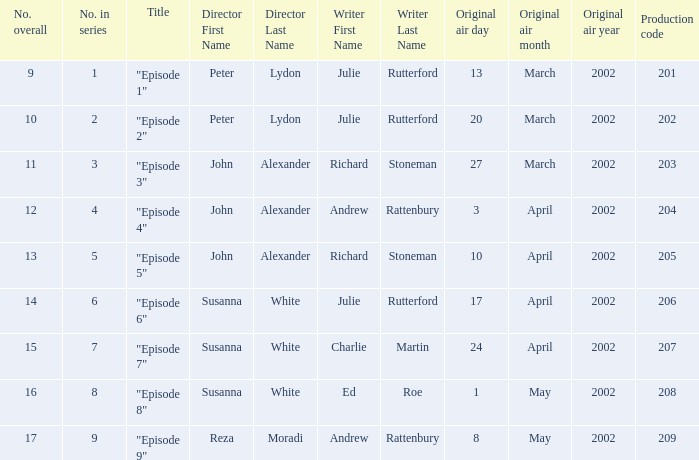When 1 is the number in series who is the director? Peter Lydon. 